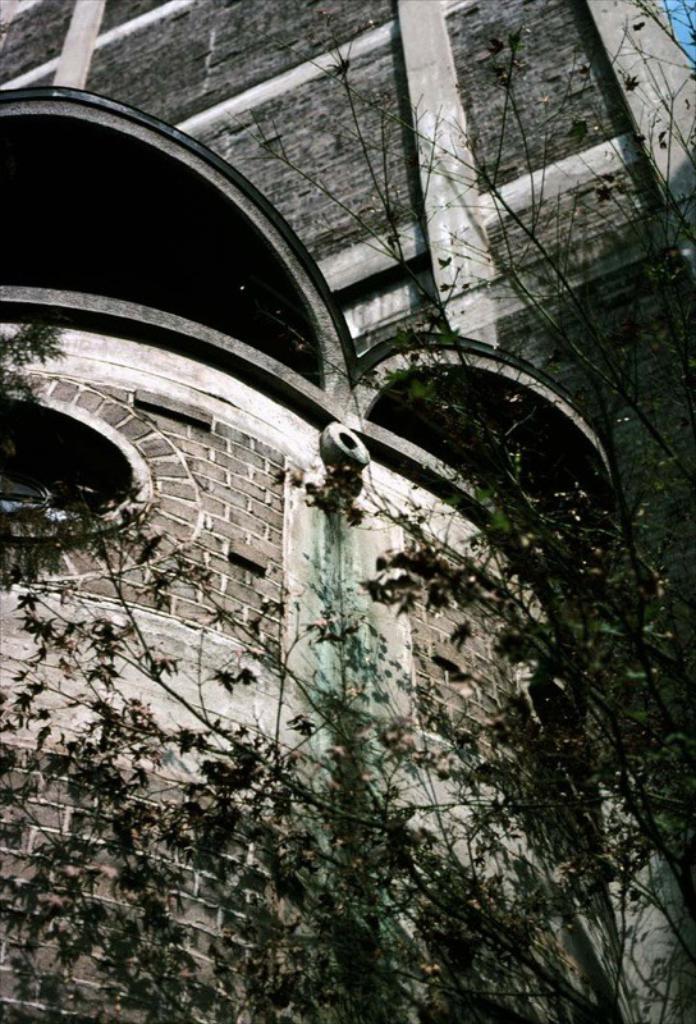In one or two sentences, can you explain what this image depicts? This is a black and white image, there is a tree and in the background there is a big building. 